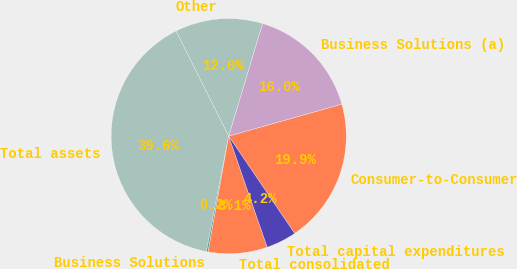<chart> <loc_0><loc_0><loc_500><loc_500><pie_chart><fcel>Consumer-to-Consumer<fcel>Business Solutions (a)<fcel>Other<fcel>Total assets<fcel>Business Solutions<fcel>Total consolidated<fcel>Total capital expenditures<nl><fcel>19.9%<fcel>15.97%<fcel>12.04%<fcel>39.57%<fcel>0.24%<fcel>8.11%<fcel>4.17%<nl></chart> 